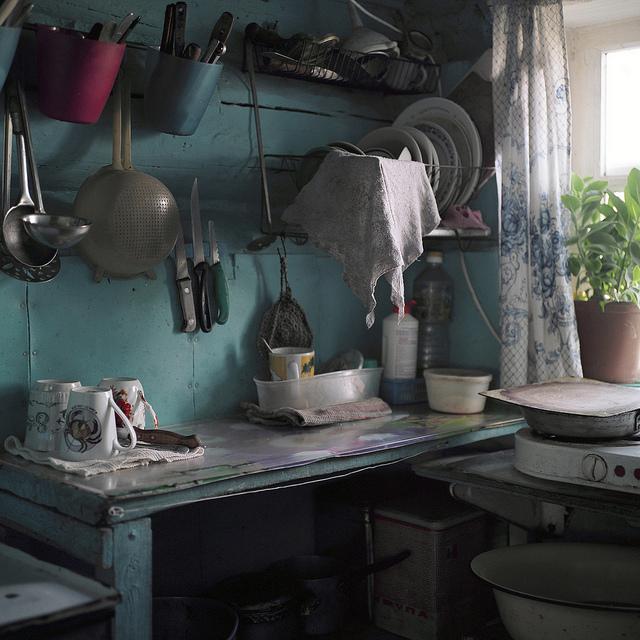How many species are on the rack?
Keep it brief. 0. How many mugs are there?
Keep it brief. 3. Is this a restaurant kitchen?
Give a very brief answer. No. How are the knives able to hang on the wall?
Give a very brief answer. Magnet. Is this a rustic kitchen?
Give a very brief answer. Yes. 